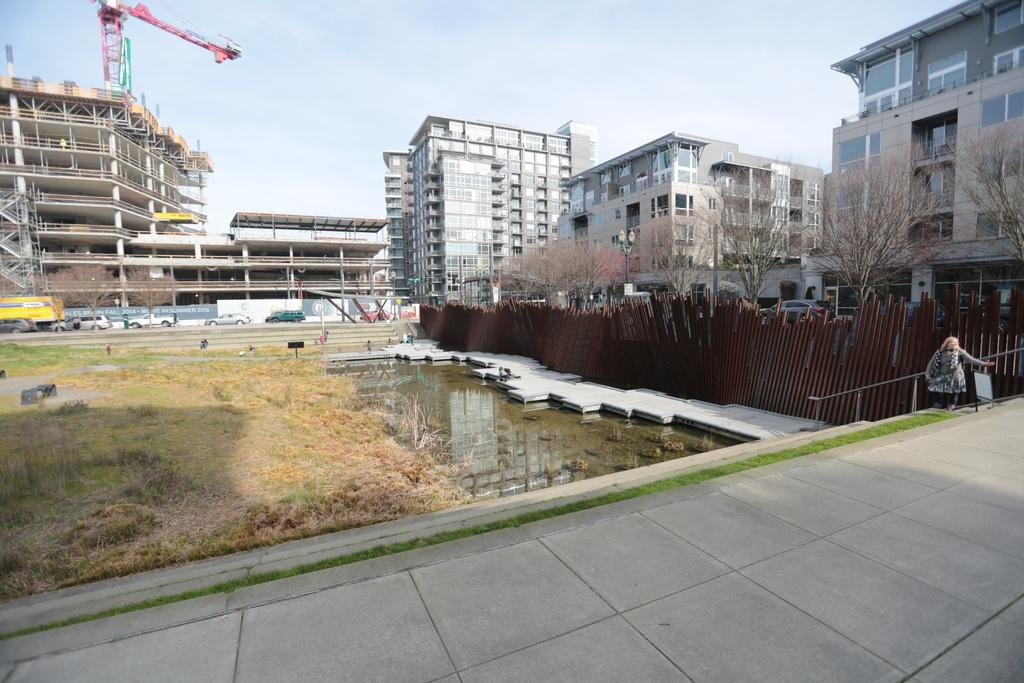What is the main subject of the image? The main subject of the image is a building under construction. Can you describe the surrounding environment? There are other buildings, trees, a wooden fence, water, grass, and a road visible in the image. What type of vehicles can be seen in the image? There are vehicles in the image. What is visible in the sky? The sky is visible in the image. Can you tell me how many hammers are being used by the beggar in the image? There is no beggar present in the image, and therefore no hammers are being used by a beggar. What emotion does the regret feel in the image? There is no emotion called "regret" depicted in the image, as it is a scene of a building under construction and its surroundings. 